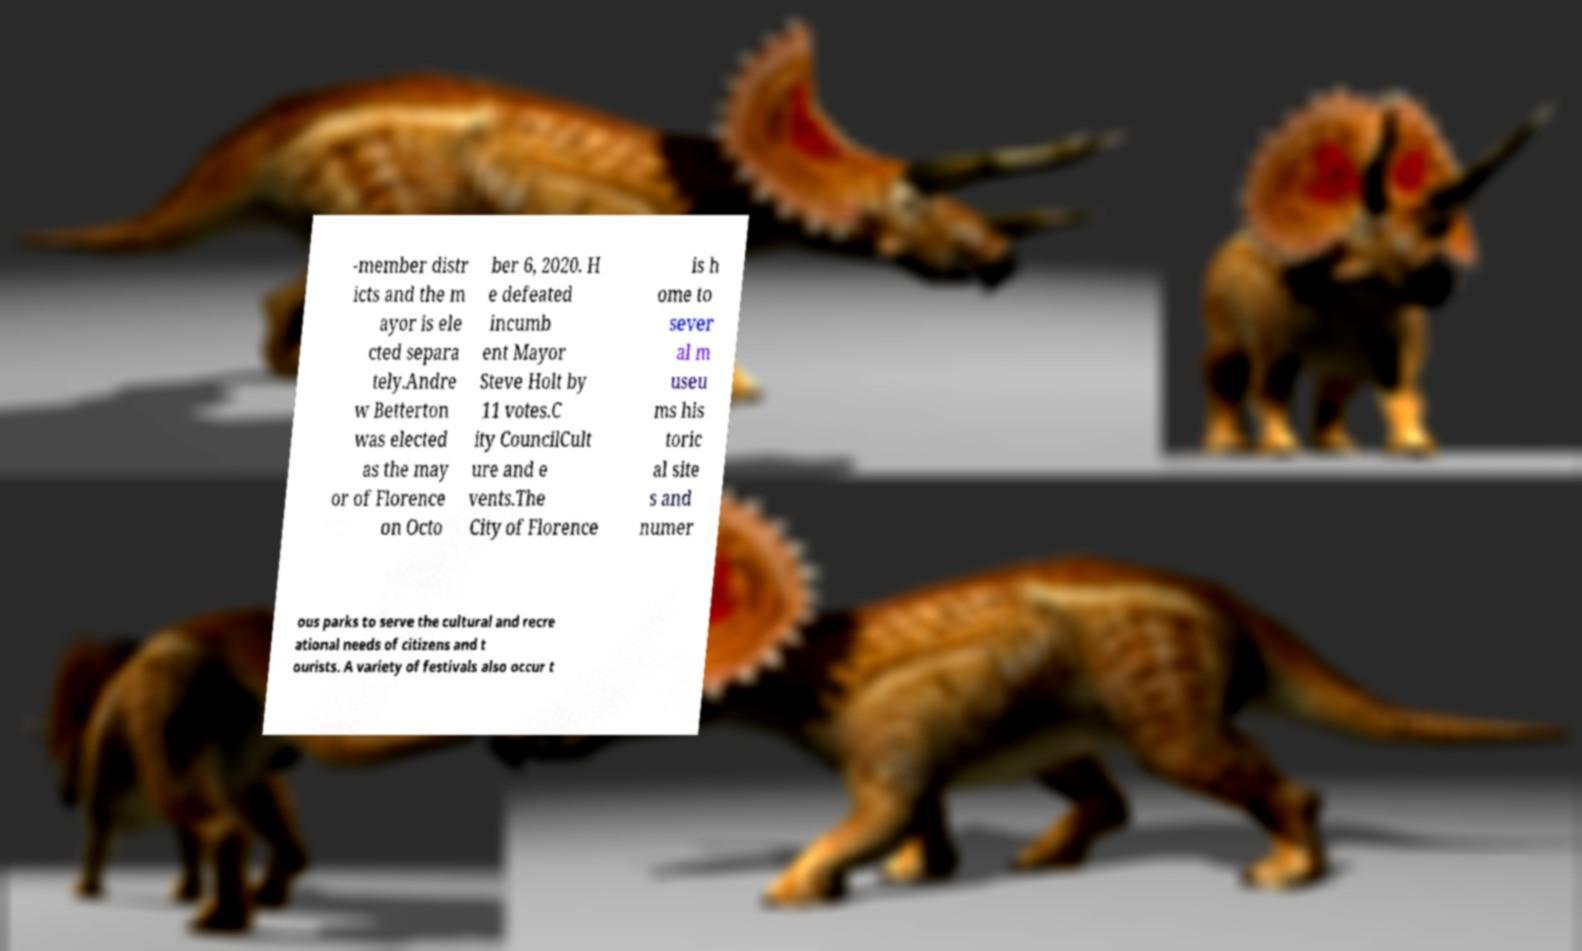For documentation purposes, I need the text within this image transcribed. Could you provide that? -member distr icts and the m ayor is ele cted separa tely.Andre w Betterton was elected as the may or of Florence on Octo ber 6, 2020. H e defeated incumb ent Mayor Steve Holt by 11 votes.C ity CouncilCult ure and e vents.The City of Florence is h ome to sever al m useu ms his toric al site s and numer ous parks to serve the cultural and recre ational needs of citizens and t ourists. A variety of festivals also occur t 